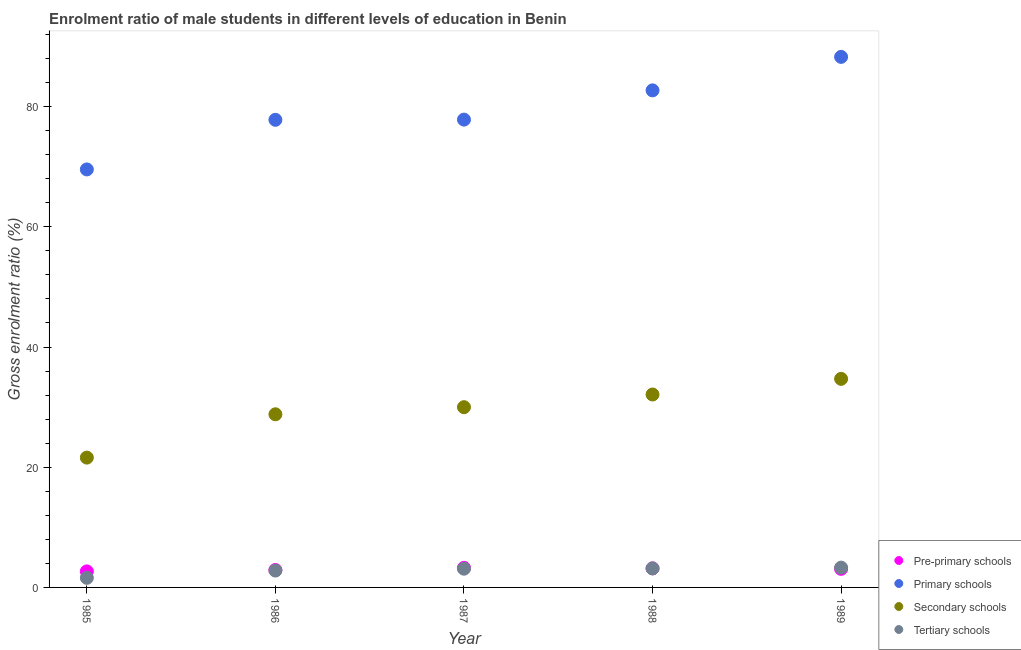How many different coloured dotlines are there?
Your answer should be compact. 4. Is the number of dotlines equal to the number of legend labels?
Keep it short and to the point. Yes. What is the gross enrolment ratio(female) in pre-primary schools in 1988?
Ensure brevity in your answer.  3.17. Across all years, what is the maximum gross enrolment ratio(female) in tertiary schools?
Your response must be concise. 3.3. Across all years, what is the minimum gross enrolment ratio(female) in secondary schools?
Your response must be concise. 21.6. In which year was the gross enrolment ratio(female) in pre-primary schools maximum?
Your answer should be compact. 1987. What is the total gross enrolment ratio(female) in primary schools in the graph?
Your answer should be very brief. 396.15. What is the difference between the gross enrolment ratio(female) in pre-primary schools in 1985 and that in 1987?
Provide a succinct answer. -0.6. What is the difference between the gross enrolment ratio(female) in secondary schools in 1989 and the gross enrolment ratio(female) in tertiary schools in 1986?
Your answer should be compact. 31.9. What is the average gross enrolment ratio(female) in pre-primary schools per year?
Provide a short and direct response. 3.02. In the year 1987, what is the difference between the gross enrolment ratio(female) in tertiary schools and gross enrolment ratio(female) in pre-primary schools?
Ensure brevity in your answer.  -0.15. In how many years, is the gross enrolment ratio(female) in tertiary schools greater than 76 %?
Offer a terse response. 0. What is the ratio of the gross enrolment ratio(female) in primary schools in 1987 to that in 1988?
Give a very brief answer. 0.94. Is the gross enrolment ratio(female) in secondary schools in 1988 less than that in 1989?
Your response must be concise. Yes. What is the difference between the highest and the second highest gross enrolment ratio(female) in primary schools?
Your answer should be very brief. 5.57. What is the difference between the highest and the lowest gross enrolment ratio(female) in primary schools?
Your answer should be very brief. 18.73. In how many years, is the gross enrolment ratio(female) in primary schools greater than the average gross enrolment ratio(female) in primary schools taken over all years?
Provide a short and direct response. 2. Is it the case that in every year, the sum of the gross enrolment ratio(female) in pre-primary schools and gross enrolment ratio(female) in primary schools is greater than the gross enrolment ratio(female) in secondary schools?
Offer a very short reply. Yes. Does the gross enrolment ratio(female) in tertiary schools monotonically increase over the years?
Provide a short and direct response. Yes. How many dotlines are there?
Make the answer very short. 4. How many years are there in the graph?
Provide a short and direct response. 5. What is the difference between two consecutive major ticks on the Y-axis?
Provide a short and direct response. 20. Does the graph contain grids?
Ensure brevity in your answer.  No. Where does the legend appear in the graph?
Your response must be concise. Bottom right. How many legend labels are there?
Ensure brevity in your answer.  4. What is the title of the graph?
Make the answer very short. Enrolment ratio of male students in different levels of education in Benin. Does "United Kingdom" appear as one of the legend labels in the graph?
Give a very brief answer. No. What is the Gross enrolment ratio (%) of Pre-primary schools in 1985?
Give a very brief answer. 2.67. What is the Gross enrolment ratio (%) of Primary schools in 1985?
Give a very brief answer. 69.55. What is the Gross enrolment ratio (%) of Secondary schools in 1985?
Offer a terse response. 21.6. What is the Gross enrolment ratio (%) of Tertiary schools in 1985?
Your response must be concise. 1.6. What is the Gross enrolment ratio (%) in Pre-primary schools in 1986?
Your answer should be very brief. 2.9. What is the Gross enrolment ratio (%) of Primary schools in 1986?
Make the answer very short. 77.8. What is the Gross enrolment ratio (%) in Secondary schools in 1986?
Offer a very short reply. 28.81. What is the Gross enrolment ratio (%) in Tertiary schools in 1986?
Your answer should be compact. 2.81. What is the Gross enrolment ratio (%) of Pre-primary schools in 1987?
Offer a very short reply. 3.26. What is the Gross enrolment ratio (%) in Primary schools in 1987?
Your answer should be compact. 77.83. What is the Gross enrolment ratio (%) of Secondary schools in 1987?
Offer a very short reply. 29.99. What is the Gross enrolment ratio (%) in Tertiary schools in 1987?
Your answer should be compact. 3.12. What is the Gross enrolment ratio (%) of Pre-primary schools in 1988?
Your response must be concise. 3.17. What is the Gross enrolment ratio (%) of Primary schools in 1988?
Give a very brief answer. 82.7. What is the Gross enrolment ratio (%) in Secondary schools in 1988?
Your answer should be very brief. 32.1. What is the Gross enrolment ratio (%) of Tertiary schools in 1988?
Offer a terse response. 3.16. What is the Gross enrolment ratio (%) of Pre-primary schools in 1989?
Give a very brief answer. 3.09. What is the Gross enrolment ratio (%) of Primary schools in 1989?
Offer a terse response. 88.27. What is the Gross enrolment ratio (%) in Secondary schools in 1989?
Provide a succinct answer. 34.7. What is the Gross enrolment ratio (%) in Tertiary schools in 1989?
Ensure brevity in your answer.  3.3. Across all years, what is the maximum Gross enrolment ratio (%) in Pre-primary schools?
Make the answer very short. 3.26. Across all years, what is the maximum Gross enrolment ratio (%) in Primary schools?
Offer a very short reply. 88.27. Across all years, what is the maximum Gross enrolment ratio (%) in Secondary schools?
Your response must be concise. 34.7. Across all years, what is the maximum Gross enrolment ratio (%) in Tertiary schools?
Your answer should be very brief. 3.3. Across all years, what is the minimum Gross enrolment ratio (%) of Pre-primary schools?
Provide a short and direct response. 2.67. Across all years, what is the minimum Gross enrolment ratio (%) in Primary schools?
Keep it short and to the point. 69.55. Across all years, what is the minimum Gross enrolment ratio (%) of Secondary schools?
Offer a terse response. 21.6. Across all years, what is the minimum Gross enrolment ratio (%) in Tertiary schools?
Give a very brief answer. 1.6. What is the total Gross enrolment ratio (%) of Pre-primary schools in the graph?
Give a very brief answer. 15.1. What is the total Gross enrolment ratio (%) in Primary schools in the graph?
Offer a terse response. 396.15. What is the total Gross enrolment ratio (%) of Secondary schools in the graph?
Ensure brevity in your answer.  147.19. What is the total Gross enrolment ratio (%) of Tertiary schools in the graph?
Make the answer very short. 13.98. What is the difference between the Gross enrolment ratio (%) of Pre-primary schools in 1985 and that in 1986?
Provide a succinct answer. -0.23. What is the difference between the Gross enrolment ratio (%) in Primary schools in 1985 and that in 1986?
Ensure brevity in your answer.  -8.25. What is the difference between the Gross enrolment ratio (%) in Secondary schools in 1985 and that in 1986?
Your answer should be very brief. -7.21. What is the difference between the Gross enrolment ratio (%) of Tertiary schools in 1985 and that in 1986?
Make the answer very short. -1.21. What is the difference between the Gross enrolment ratio (%) of Pre-primary schools in 1985 and that in 1987?
Provide a short and direct response. -0.6. What is the difference between the Gross enrolment ratio (%) of Primary schools in 1985 and that in 1987?
Offer a terse response. -8.29. What is the difference between the Gross enrolment ratio (%) in Secondary schools in 1985 and that in 1987?
Provide a short and direct response. -8.39. What is the difference between the Gross enrolment ratio (%) in Tertiary schools in 1985 and that in 1987?
Your response must be concise. -1.52. What is the difference between the Gross enrolment ratio (%) in Pre-primary schools in 1985 and that in 1988?
Offer a terse response. -0.5. What is the difference between the Gross enrolment ratio (%) in Primary schools in 1985 and that in 1988?
Offer a very short reply. -13.16. What is the difference between the Gross enrolment ratio (%) of Secondary schools in 1985 and that in 1988?
Offer a terse response. -10.5. What is the difference between the Gross enrolment ratio (%) in Tertiary schools in 1985 and that in 1988?
Make the answer very short. -1.57. What is the difference between the Gross enrolment ratio (%) of Pre-primary schools in 1985 and that in 1989?
Make the answer very short. -0.42. What is the difference between the Gross enrolment ratio (%) of Primary schools in 1985 and that in 1989?
Give a very brief answer. -18.73. What is the difference between the Gross enrolment ratio (%) in Secondary schools in 1985 and that in 1989?
Make the answer very short. -13.1. What is the difference between the Gross enrolment ratio (%) in Tertiary schools in 1985 and that in 1989?
Your answer should be very brief. -1.7. What is the difference between the Gross enrolment ratio (%) in Pre-primary schools in 1986 and that in 1987?
Provide a succinct answer. -0.36. What is the difference between the Gross enrolment ratio (%) of Primary schools in 1986 and that in 1987?
Give a very brief answer. -0.03. What is the difference between the Gross enrolment ratio (%) in Secondary schools in 1986 and that in 1987?
Offer a very short reply. -1.18. What is the difference between the Gross enrolment ratio (%) of Tertiary schools in 1986 and that in 1987?
Give a very brief answer. -0.31. What is the difference between the Gross enrolment ratio (%) in Pre-primary schools in 1986 and that in 1988?
Provide a succinct answer. -0.27. What is the difference between the Gross enrolment ratio (%) of Primary schools in 1986 and that in 1988?
Give a very brief answer. -4.9. What is the difference between the Gross enrolment ratio (%) of Secondary schools in 1986 and that in 1988?
Provide a short and direct response. -3.29. What is the difference between the Gross enrolment ratio (%) of Tertiary schools in 1986 and that in 1988?
Your response must be concise. -0.36. What is the difference between the Gross enrolment ratio (%) of Pre-primary schools in 1986 and that in 1989?
Provide a succinct answer. -0.19. What is the difference between the Gross enrolment ratio (%) of Primary schools in 1986 and that in 1989?
Provide a succinct answer. -10.47. What is the difference between the Gross enrolment ratio (%) of Secondary schools in 1986 and that in 1989?
Ensure brevity in your answer.  -5.9. What is the difference between the Gross enrolment ratio (%) of Tertiary schools in 1986 and that in 1989?
Offer a very short reply. -0.49. What is the difference between the Gross enrolment ratio (%) of Pre-primary schools in 1987 and that in 1988?
Keep it short and to the point. 0.09. What is the difference between the Gross enrolment ratio (%) of Primary schools in 1987 and that in 1988?
Provide a short and direct response. -4.87. What is the difference between the Gross enrolment ratio (%) in Secondary schools in 1987 and that in 1988?
Provide a short and direct response. -2.11. What is the difference between the Gross enrolment ratio (%) of Tertiary schools in 1987 and that in 1988?
Offer a terse response. -0.05. What is the difference between the Gross enrolment ratio (%) of Pre-primary schools in 1987 and that in 1989?
Make the answer very short. 0.17. What is the difference between the Gross enrolment ratio (%) of Primary schools in 1987 and that in 1989?
Offer a very short reply. -10.44. What is the difference between the Gross enrolment ratio (%) in Secondary schools in 1987 and that in 1989?
Keep it short and to the point. -4.71. What is the difference between the Gross enrolment ratio (%) of Tertiary schools in 1987 and that in 1989?
Your answer should be very brief. -0.18. What is the difference between the Gross enrolment ratio (%) in Pre-primary schools in 1988 and that in 1989?
Make the answer very short. 0.08. What is the difference between the Gross enrolment ratio (%) of Primary schools in 1988 and that in 1989?
Keep it short and to the point. -5.57. What is the difference between the Gross enrolment ratio (%) of Secondary schools in 1988 and that in 1989?
Provide a short and direct response. -2.61. What is the difference between the Gross enrolment ratio (%) of Tertiary schools in 1988 and that in 1989?
Ensure brevity in your answer.  -0.13. What is the difference between the Gross enrolment ratio (%) in Pre-primary schools in 1985 and the Gross enrolment ratio (%) in Primary schools in 1986?
Your response must be concise. -75.13. What is the difference between the Gross enrolment ratio (%) of Pre-primary schools in 1985 and the Gross enrolment ratio (%) of Secondary schools in 1986?
Your response must be concise. -26.14. What is the difference between the Gross enrolment ratio (%) in Pre-primary schools in 1985 and the Gross enrolment ratio (%) in Tertiary schools in 1986?
Your answer should be compact. -0.14. What is the difference between the Gross enrolment ratio (%) of Primary schools in 1985 and the Gross enrolment ratio (%) of Secondary schools in 1986?
Offer a very short reply. 40.74. What is the difference between the Gross enrolment ratio (%) of Primary schools in 1985 and the Gross enrolment ratio (%) of Tertiary schools in 1986?
Provide a short and direct response. 66.74. What is the difference between the Gross enrolment ratio (%) of Secondary schools in 1985 and the Gross enrolment ratio (%) of Tertiary schools in 1986?
Your answer should be very brief. 18.79. What is the difference between the Gross enrolment ratio (%) of Pre-primary schools in 1985 and the Gross enrolment ratio (%) of Primary schools in 1987?
Your answer should be very brief. -75.16. What is the difference between the Gross enrolment ratio (%) of Pre-primary schools in 1985 and the Gross enrolment ratio (%) of Secondary schools in 1987?
Ensure brevity in your answer.  -27.32. What is the difference between the Gross enrolment ratio (%) in Pre-primary schools in 1985 and the Gross enrolment ratio (%) in Tertiary schools in 1987?
Give a very brief answer. -0.45. What is the difference between the Gross enrolment ratio (%) in Primary schools in 1985 and the Gross enrolment ratio (%) in Secondary schools in 1987?
Ensure brevity in your answer.  39.56. What is the difference between the Gross enrolment ratio (%) of Primary schools in 1985 and the Gross enrolment ratio (%) of Tertiary schools in 1987?
Offer a very short reply. 66.43. What is the difference between the Gross enrolment ratio (%) in Secondary schools in 1985 and the Gross enrolment ratio (%) in Tertiary schools in 1987?
Your response must be concise. 18.48. What is the difference between the Gross enrolment ratio (%) of Pre-primary schools in 1985 and the Gross enrolment ratio (%) of Primary schools in 1988?
Provide a succinct answer. -80.03. What is the difference between the Gross enrolment ratio (%) of Pre-primary schools in 1985 and the Gross enrolment ratio (%) of Secondary schools in 1988?
Keep it short and to the point. -29.43. What is the difference between the Gross enrolment ratio (%) in Pre-primary schools in 1985 and the Gross enrolment ratio (%) in Tertiary schools in 1988?
Make the answer very short. -0.5. What is the difference between the Gross enrolment ratio (%) in Primary schools in 1985 and the Gross enrolment ratio (%) in Secondary schools in 1988?
Ensure brevity in your answer.  37.45. What is the difference between the Gross enrolment ratio (%) of Primary schools in 1985 and the Gross enrolment ratio (%) of Tertiary schools in 1988?
Provide a succinct answer. 66.38. What is the difference between the Gross enrolment ratio (%) of Secondary schools in 1985 and the Gross enrolment ratio (%) of Tertiary schools in 1988?
Offer a terse response. 18.44. What is the difference between the Gross enrolment ratio (%) in Pre-primary schools in 1985 and the Gross enrolment ratio (%) in Primary schools in 1989?
Offer a terse response. -85.6. What is the difference between the Gross enrolment ratio (%) in Pre-primary schools in 1985 and the Gross enrolment ratio (%) in Secondary schools in 1989?
Make the answer very short. -32.04. What is the difference between the Gross enrolment ratio (%) of Pre-primary schools in 1985 and the Gross enrolment ratio (%) of Tertiary schools in 1989?
Offer a very short reply. -0.63. What is the difference between the Gross enrolment ratio (%) in Primary schools in 1985 and the Gross enrolment ratio (%) in Secondary schools in 1989?
Offer a very short reply. 34.84. What is the difference between the Gross enrolment ratio (%) in Primary schools in 1985 and the Gross enrolment ratio (%) in Tertiary schools in 1989?
Provide a succinct answer. 66.25. What is the difference between the Gross enrolment ratio (%) in Secondary schools in 1985 and the Gross enrolment ratio (%) in Tertiary schools in 1989?
Offer a very short reply. 18.3. What is the difference between the Gross enrolment ratio (%) of Pre-primary schools in 1986 and the Gross enrolment ratio (%) of Primary schools in 1987?
Offer a terse response. -74.93. What is the difference between the Gross enrolment ratio (%) in Pre-primary schools in 1986 and the Gross enrolment ratio (%) in Secondary schools in 1987?
Your answer should be very brief. -27.09. What is the difference between the Gross enrolment ratio (%) in Pre-primary schools in 1986 and the Gross enrolment ratio (%) in Tertiary schools in 1987?
Your answer should be very brief. -0.22. What is the difference between the Gross enrolment ratio (%) in Primary schools in 1986 and the Gross enrolment ratio (%) in Secondary schools in 1987?
Provide a short and direct response. 47.81. What is the difference between the Gross enrolment ratio (%) in Primary schools in 1986 and the Gross enrolment ratio (%) in Tertiary schools in 1987?
Offer a terse response. 74.68. What is the difference between the Gross enrolment ratio (%) in Secondary schools in 1986 and the Gross enrolment ratio (%) in Tertiary schools in 1987?
Make the answer very short. 25.69. What is the difference between the Gross enrolment ratio (%) in Pre-primary schools in 1986 and the Gross enrolment ratio (%) in Primary schools in 1988?
Keep it short and to the point. -79.8. What is the difference between the Gross enrolment ratio (%) in Pre-primary schools in 1986 and the Gross enrolment ratio (%) in Secondary schools in 1988?
Provide a short and direct response. -29.2. What is the difference between the Gross enrolment ratio (%) of Pre-primary schools in 1986 and the Gross enrolment ratio (%) of Tertiary schools in 1988?
Make the answer very short. -0.26. What is the difference between the Gross enrolment ratio (%) of Primary schools in 1986 and the Gross enrolment ratio (%) of Secondary schools in 1988?
Offer a terse response. 45.7. What is the difference between the Gross enrolment ratio (%) of Primary schools in 1986 and the Gross enrolment ratio (%) of Tertiary schools in 1988?
Keep it short and to the point. 74.64. What is the difference between the Gross enrolment ratio (%) in Secondary schools in 1986 and the Gross enrolment ratio (%) in Tertiary schools in 1988?
Provide a short and direct response. 25.64. What is the difference between the Gross enrolment ratio (%) in Pre-primary schools in 1986 and the Gross enrolment ratio (%) in Primary schools in 1989?
Offer a terse response. -85.37. What is the difference between the Gross enrolment ratio (%) of Pre-primary schools in 1986 and the Gross enrolment ratio (%) of Secondary schools in 1989?
Your answer should be very brief. -31.8. What is the difference between the Gross enrolment ratio (%) in Pre-primary schools in 1986 and the Gross enrolment ratio (%) in Tertiary schools in 1989?
Make the answer very short. -0.4. What is the difference between the Gross enrolment ratio (%) in Primary schools in 1986 and the Gross enrolment ratio (%) in Secondary schools in 1989?
Give a very brief answer. 43.1. What is the difference between the Gross enrolment ratio (%) of Primary schools in 1986 and the Gross enrolment ratio (%) of Tertiary schools in 1989?
Offer a very short reply. 74.5. What is the difference between the Gross enrolment ratio (%) in Secondary schools in 1986 and the Gross enrolment ratio (%) in Tertiary schools in 1989?
Offer a terse response. 25.51. What is the difference between the Gross enrolment ratio (%) of Pre-primary schools in 1987 and the Gross enrolment ratio (%) of Primary schools in 1988?
Your answer should be very brief. -79.44. What is the difference between the Gross enrolment ratio (%) in Pre-primary schools in 1987 and the Gross enrolment ratio (%) in Secondary schools in 1988?
Provide a succinct answer. -28.83. What is the difference between the Gross enrolment ratio (%) of Pre-primary schools in 1987 and the Gross enrolment ratio (%) of Tertiary schools in 1988?
Offer a very short reply. 0.1. What is the difference between the Gross enrolment ratio (%) of Primary schools in 1987 and the Gross enrolment ratio (%) of Secondary schools in 1988?
Provide a short and direct response. 45.73. What is the difference between the Gross enrolment ratio (%) of Primary schools in 1987 and the Gross enrolment ratio (%) of Tertiary schools in 1988?
Your response must be concise. 74.67. What is the difference between the Gross enrolment ratio (%) in Secondary schools in 1987 and the Gross enrolment ratio (%) in Tertiary schools in 1988?
Provide a succinct answer. 26.83. What is the difference between the Gross enrolment ratio (%) of Pre-primary schools in 1987 and the Gross enrolment ratio (%) of Primary schools in 1989?
Provide a succinct answer. -85.01. What is the difference between the Gross enrolment ratio (%) in Pre-primary schools in 1987 and the Gross enrolment ratio (%) in Secondary schools in 1989?
Keep it short and to the point. -31.44. What is the difference between the Gross enrolment ratio (%) of Pre-primary schools in 1987 and the Gross enrolment ratio (%) of Tertiary schools in 1989?
Offer a very short reply. -0.03. What is the difference between the Gross enrolment ratio (%) of Primary schools in 1987 and the Gross enrolment ratio (%) of Secondary schools in 1989?
Offer a terse response. 43.13. What is the difference between the Gross enrolment ratio (%) of Primary schools in 1987 and the Gross enrolment ratio (%) of Tertiary schools in 1989?
Keep it short and to the point. 74.53. What is the difference between the Gross enrolment ratio (%) in Secondary schools in 1987 and the Gross enrolment ratio (%) in Tertiary schools in 1989?
Your answer should be very brief. 26.69. What is the difference between the Gross enrolment ratio (%) of Pre-primary schools in 1988 and the Gross enrolment ratio (%) of Primary schools in 1989?
Offer a terse response. -85.1. What is the difference between the Gross enrolment ratio (%) in Pre-primary schools in 1988 and the Gross enrolment ratio (%) in Secondary schools in 1989?
Offer a very short reply. -31.53. What is the difference between the Gross enrolment ratio (%) in Pre-primary schools in 1988 and the Gross enrolment ratio (%) in Tertiary schools in 1989?
Your response must be concise. -0.13. What is the difference between the Gross enrolment ratio (%) of Primary schools in 1988 and the Gross enrolment ratio (%) of Secondary schools in 1989?
Offer a terse response. 48. What is the difference between the Gross enrolment ratio (%) in Primary schools in 1988 and the Gross enrolment ratio (%) in Tertiary schools in 1989?
Keep it short and to the point. 79.4. What is the difference between the Gross enrolment ratio (%) in Secondary schools in 1988 and the Gross enrolment ratio (%) in Tertiary schools in 1989?
Offer a very short reply. 28.8. What is the average Gross enrolment ratio (%) of Pre-primary schools per year?
Your answer should be compact. 3.02. What is the average Gross enrolment ratio (%) of Primary schools per year?
Your answer should be very brief. 79.23. What is the average Gross enrolment ratio (%) of Secondary schools per year?
Offer a very short reply. 29.44. What is the average Gross enrolment ratio (%) in Tertiary schools per year?
Offer a terse response. 2.8. In the year 1985, what is the difference between the Gross enrolment ratio (%) of Pre-primary schools and Gross enrolment ratio (%) of Primary schools?
Offer a very short reply. -66.88. In the year 1985, what is the difference between the Gross enrolment ratio (%) in Pre-primary schools and Gross enrolment ratio (%) in Secondary schools?
Your answer should be compact. -18.93. In the year 1985, what is the difference between the Gross enrolment ratio (%) in Pre-primary schools and Gross enrolment ratio (%) in Tertiary schools?
Provide a succinct answer. 1.07. In the year 1985, what is the difference between the Gross enrolment ratio (%) in Primary schools and Gross enrolment ratio (%) in Secondary schools?
Your answer should be compact. 47.95. In the year 1985, what is the difference between the Gross enrolment ratio (%) in Primary schools and Gross enrolment ratio (%) in Tertiary schools?
Offer a very short reply. 67.95. In the year 1985, what is the difference between the Gross enrolment ratio (%) of Secondary schools and Gross enrolment ratio (%) of Tertiary schools?
Offer a terse response. 20. In the year 1986, what is the difference between the Gross enrolment ratio (%) of Pre-primary schools and Gross enrolment ratio (%) of Primary schools?
Give a very brief answer. -74.9. In the year 1986, what is the difference between the Gross enrolment ratio (%) of Pre-primary schools and Gross enrolment ratio (%) of Secondary schools?
Provide a succinct answer. -25.9. In the year 1986, what is the difference between the Gross enrolment ratio (%) in Pre-primary schools and Gross enrolment ratio (%) in Tertiary schools?
Your answer should be very brief. 0.1. In the year 1986, what is the difference between the Gross enrolment ratio (%) of Primary schools and Gross enrolment ratio (%) of Secondary schools?
Offer a terse response. 48.99. In the year 1986, what is the difference between the Gross enrolment ratio (%) of Primary schools and Gross enrolment ratio (%) of Tertiary schools?
Your response must be concise. 74.99. In the year 1986, what is the difference between the Gross enrolment ratio (%) in Secondary schools and Gross enrolment ratio (%) in Tertiary schools?
Your response must be concise. 26. In the year 1987, what is the difference between the Gross enrolment ratio (%) of Pre-primary schools and Gross enrolment ratio (%) of Primary schools?
Give a very brief answer. -74.57. In the year 1987, what is the difference between the Gross enrolment ratio (%) in Pre-primary schools and Gross enrolment ratio (%) in Secondary schools?
Ensure brevity in your answer.  -26.72. In the year 1987, what is the difference between the Gross enrolment ratio (%) of Pre-primary schools and Gross enrolment ratio (%) of Tertiary schools?
Your response must be concise. 0.15. In the year 1987, what is the difference between the Gross enrolment ratio (%) in Primary schools and Gross enrolment ratio (%) in Secondary schools?
Provide a short and direct response. 47.84. In the year 1987, what is the difference between the Gross enrolment ratio (%) in Primary schools and Gross enrolment ratio (%) in Tertiary schools?
Offer a very short reply. 74.71. In the year 1987, what is the difference between the Gross enrolment ratio (%) in Secondary schools and Gross enrolment ratio (%) in Tertiary schools?
Make the answer very short. 26.87. In the year 1988, what is the difference between the Gross enrolment ratio (%) in Pre-primary schools and Gross enrolment ratio (%) in Primary schools?
Offer a very short reply. -79.53. In the year 1988, what is the difference between the Gross enrolment ratio (%) of Pre-primary schools and Gross enrolment ratio (%) of Secondary schools?
Your answer should be compact. -28.93. In the year 1988, what is the difference between the Gross enrolment ratio (%) in Pre-primary schools and Gross enrolment ratio (%) in Tertiary schools?
Your answer should be very brief. 0.01. In the year 1988, what is the difference between the Gross enrolment ratio (%) in Primary schools and Gross enrolment ratio (%) in Secondary schools?
Give a very brief answer. 50.6. In the year 1988, what is the difference between the Gross enrolment ratio (%) in Primary schools and Gross enrolment ratio (%) in Tertiary schools?
Provide a succinct answer. 79.54. In the year 1988, what is the difference between the Gross enrolment ratio (%) in Secondary schools and Gross enrolment ratio (%) in Tertiary schools?
Your answer should be very brief. 28.93. In the year 1989, what is the difference between the Gross enrolment ratio (%) of Pre-primary schools and Gross enrolment ratio (%) of Primary schools?
Offer a very short reply. -85.18. In the year 1989, what is the difference between the Gross enrolment ratio (%) of Pre-primary schools and Gross enrolment ratio (%) of Secondary schools?
Your response must be concise. -31.61. In the year 1989, what is the difference between the Gross enrolment ratio (%) in Pre-primary schools and Gross enrolment ratio (%) in Tertiary schools?
Your response must be concise. -0.21. In the year 1989, what is the difference between the Gross enrolment ratio (%) in Primary schools and Gross enrolment ratio (%) in Secondary schools?
Keep it short and to the point. 53.57. In the year 1989, what is the difference between the Gross enrolment ratio (%) of Primary schools and Gross enrolment ratio (%) of Tertiary schools?
Give a very brief answer. 84.97. In the year 1989, what is the difference between the Gross enrolment ratio (%) in Secondary schools and Gross enrolment ratio (%) in Tertiary schools?
Give a very brief answer. 31.41. What is the ratio of the Gross enrolment ratio (%) in Pre-primary schools in 1985 to that in 1986?
Offer a terse response. 0.92. What is the ratio of the Gross enrolment ratio (%) of Primary schools in 1985 to that in 1986?
Your response must be concise. 0.89. What is the ratio of the Gross enrolment ratio (%) of Secondary schools in 1985 to that in 1986?
Your response must be concise. 0.75. What is the ratio of the Gross enrolment ratio (%) of Tertiary schools in 1985 to that in 1986?
Keep it short and to the point. 0.57. What is the ratio of the Gross enrolment ratio (%) of Pre-primary schools in 1985 to that in 1987?
Offer a terse response. 0.82. What is the ratio of the Gross enrolment ratio (%) of Primary schools in 1985 to that in 1987?
Your answer should be compact. 0.89. What is the ratio of the Gross enrolment ratio (%) in Secondary schools in 1985 to that in 1987?
Offer a very short reply. 0.72. What is the ratio of the Gross enrolment ratio (%) of Tertiary schools in 1985 to that in 1987?
Give a very brief answer. 0.51. What is the ratio of the Gross enrolment ratio (%) in Pre-primary schools in 1985 to that in 1988?
Your answer should be compact. 0.84. What is the ratio of the Gross enrolment ratio (%) in Primary schools in 1985 to that in 1988?
Make the answer very short. 0.84. What is the ratio of the Gross enrolment ratio (%) of Secondary schools in 1985 to that in 1988?
Offer a terse response. 0.67. What is the ratio of the Gross enrolment ratio (%) of Tertiary schools in 1985 to that in 1988?
Provide a succinct answer. 0.5. What is the ratio of the Gross enrolment ratio (%) in Pre-primary schools in 1985 to that in 1989?
Provide a short and direct response. 0.86. What is the ratio of the Gross enrolment ratio (%) of Primary schools in 1985 to that in 1989?
Give a very brief answer. 0.79. What is the ratio of the Gross enrolment ratio (%) of Secondary schools in 1985 to that in 1989?
Ensure brevity in your answer.  0.62. What is the ratio of the Gross enrolment ratio (%) of Tertiary schools in 1985 to that in 1989?
Your response must be concise. 0.48. What is the ratio of the Gross enrolment ratio (%) of Pre-primary schools in 1986 to that in 1987?
Provide a succinct answer. 0.89. What is the ratio of the Gross enrolment ratio (%) of Secondary schools in 1986 to that in 1987?
Provide a short and direct response. 0.96. What is the ratio of the Gross enrolment ratio (%) of Tertiary schools in 1986 to that in 1987?
Your answer should be very brief. 0.9. What is the ratio of the Gross enrolment ratio (%) in Pre-primary schools in 1986 to that in 1988?
Offer a very short reply. 0.91. What is the ratio of the Gross enrolment ratio (%) of Primary schools in 1986 to that in 1988?
Keep it short and to the point. 0.94. What is the ratio of the Gross enrolment ratio (%) in Secondary schools in 1986 to that in 1988?
Give a very brief answer. 0.9. What is the ratio of the Gross enrolment ratio (%) in Tertiary schools in 1986 to that in 1988?
Your answer should be very brief. 0.89. What is the ratio of the Gross enrolment ratio (%) in Pre-primary schools in 1986 to that in 1989?
Ensure brevity in your answer.  0.94. What is the ratio of the Gross enrolment ratio (%) in Primary schools in 1986 to that in 1989?
Offer a very short reply. 0.88. What is the ratio of the Gross enrolment ratio (%) in Secondary schools in 1986 to that in 1989?
Make the answer very short. 0.83. What is the ratio of the Gross enrolment ratio (%) in Tertiary schools in 1986 to that in 1989?
Your answer should be compact. 0.85. What is the ratio of the Gross enrolment ratio (%) in Pre-primary schools in 1987 to that in 1988?
Keep it short and to the point. 1.03. What is the ratio of the Gross enrolment ratio (%) in Primary schools in 1987 to that in 1988?
Provide a succinct answer. 0.94. What is the ratio of the Gross enrolment ratio (%) of Secondary schools in 1987 to that in 1988?
Your answer should be very brief. 0.93. What is the ratio of the Gross enrolment ratio (%) of Tertiary schools in 1987 to that in 1988?
Your response must be concise. 0.99. What is the ratio of the Gross enrolment ratio (%) of Pre-primary schools in 1987 to that in 1989?
Keep it short and to the point. 1.06. What is the ratio of the Gross enrolment ratio (%) of Primary schools in 1987 to that in 1989?
Your answer should be very brief. 0.88. What is the ratio of the Gross enrolment ratio (%) in Secondary schools in 1987 to that in 1989?
Offer a terse response. 0.86. What is the ratio of the Gross enrolment ratio (%) in Tertiary schools in 1987 to that in 1989?
Your answer should be compact. 0.95. What is the ratio of the Gross enrolment ratio (%) in Pre-primary schools in 1988 to that in 1989?
Keep it short and to the point. 1.03. What is the ratio of the Gross enrolment ratio (%) in Primary schools in 1988 to that in 1989?
Your response must be concise. 0.94. What is the ratio of the Gross enrolment ratio (%) of Secondary schools in 1988 to that in 1989?
Keep it short and to the point. 0.92. What is the ratio of the Gross enrolment ratio (%) in Tertiary schools in 1988 to that in 1989?
Keep it short and to the point. 0.96. What is the difference between the highest and the second highest Gross enrolment ratio (%) in Pre-primary schools?
Keep it short and to the point. 0.09. What is the difference between the highest and the second highest Gross enrolment ratio (%) of Primary schools?
Provide a succinct answer. 5.57. What is the difference between the highest and the second highest Gross enrolment ratio (%) of Secondary schools?
Your answer should be very brief. 2.61. What is the difference between the highest and the second highest Gross enrolment ratio (%) in Tertiary schools?
Provide a short and direct response. 0.13. What is the difference between the highest and the lowest Gross enrolment ratio (%) in Pre-primary schools?
Your answer should be compact. 0.6. What is the difference between the highest and the lowest Gross enrolment ratio (%) in Primary schools?
Your answer should be very brief. 18.73. What is the difference between the highest and the lowest Gross enrolment ratio (%) of Secondary schools?
Offer a terse response. 13.1. What is the difference between the highest and the lowest Gross enrolment ratio (%) of Tertiary schools?
Your response must be concise. 1.7. 